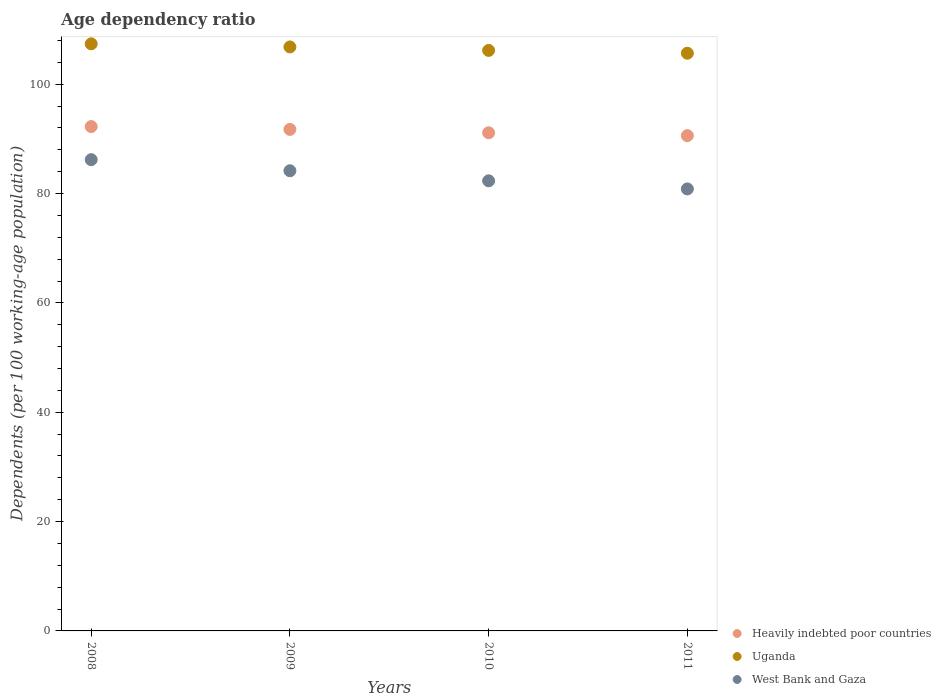Is the number of dotlines equal to the number of legend labels?
Your answer should be very brief. Yes. What is the age dependency ratio in in Uganda in 2009?
Offer a terse response. 106.83. Across all years, what is the maximum age dependency ratio in in Uganda?
Offer a terse response. 107.39. Across all years, what is the minimum age dependency ratio in in Heavily indebted poor countries?
Give a very brief answer. 90.6. What is the total age dependency ratio in in Uganda in the graph?
Provide a succinct answer. 426.08. What is the difference between the age dependency ratio in in Heavily indebted poor countries in 2009 and that in 2011?
Ensure brevity in your answer.  1.15. What is the difference between the age dependency ratio in in Heavily indebted poor countries in 2011 and the age dependency ratio in in West Bank and Gaza in 2008?
Offer a very short reply. 4.39. What is the average age dependency ratio in in Heavily indebted poor countries per year?
Keep it short and to the point. 91.43. In the year 2010, what is the difference between the age dependency ratio in in Uganda and age dependency ratio in in West Bank and Gaza?
Your answer should be very brief. 23.85. What is the ratio of the age dependency ratio in in West Bank and Gaza in 2010 to that in 2011?
Offer a very short reply. 1.02. Is the difference between the age dependency ratio in in Uganda in 2010 and 2011 greater than the difference between the age dependency ratio in in West Bank and Gaza in 2010 and 2011?
Your answer should be very brief. No. What is the difference between the highest and the second highest age dependency ratio in in Uganda?
Provide a succinct answer. 0.57. What is the difference between the highest and the lowest age dependency ratio in in Heavily indebted poor countries?
Your answer should be very brief. 1.66. In how many years, is the age dependency ratio in in Uganda greater than the average age dependency ratio in in Uganda taken over all years?
Your answer should be compact. 2. Is the sum of the age dependency ratio in in Uganda in 2008 and 2011 greater than the maximum age dependency ratio in in West Bank and Gaza across all years?
Your answer should be compact. Yes. How many dotlines are there?
Provide a succinct answer. 3. Does the graph contain any zero values?
Make the answer very short. No. Does the graph contain grids?
Your response must be concise. No. How many legend labels are there?
Offer a very short reply. 3. How are the legend labels stacked?
Make the answer very short. Vertical. What is the title of the graph?
Keep it short and to the point. Age dependency ratio. What is the label or title of the Y-axis?
Offer a very short reply. Dependents (per 100 working-age population). What is the Dependents (per 100 working-age population) of Heavily indebted poor countries in 2008?
Ensure brevity in your answer.  92.26. What is the Dependents (per 100 working-age population) of Uganda in 2008?
Ensure brevity in your answer.  107.39. What is the Dependents (per 100 working-age population) in West Bank and Gaza in 2008?
Offer a very short reply. 86.2. What is the Dependents (per 100 working-age population) in Heavily indebted poor countries in 2009?
Your response must be concise. 91.74. What is the Dependents (per 100 working-age population) of Uganda in 2009?
Ensure brevity in your answer.  106.83. What is the Dependents (per 100 working-age population) of West Bank and Gaza in 2009?
Offer a very short reply. 84.17. What is the Dependents (per 100 working-age population) in Heavily indebted poor countries in 2010?
Give a very brief answer. 91.12. What is the Dependents (per 100 working-age population) of Uganda in 2010?
Give a very brief answer. 106.19. What is the Dependents (per 100 working-age population) in West Bank and Gaza in 2010?
Provide a succinct answer. 82.33. What is the Dependents (per 100 working-age population) in Heavily indebted poor countries in 2011?
Your answer should be very brief. 90.6. What is the Dependents (per 100 working-age population) of Uganda in 2011?
Ensure brevity in your answer.  105.68. What is the Dependents (per 100 working-age population) of West Bank and Gaza in 2011?
Give a very brief answer. 80.85. Across all years, what is the maximum Dependents (per 100 working-age population) in Heavily indebted poor countries?
Offer a terse response. 92.26. Across all years, what is the maximum Dependents (per 100 working-age population) in Uganda?
Provide a short and direct response. 107.39. Across all years, what is the maximum Dependents (per 100 working-age population) in West Bank and Gaza?
Keep it short and to the point. 86.2. Across all years, what is the minimum Dependents (per 100 working-age population) in Heavily indebted poor countries?
Your answer should be compact. 90.6. Across all years, what is the minimum Dependents (per 100 working-age population) in Uganda?
Your response must be concise. 105.68. Across all years, what is the minimum Dependents (per 100 working-age population) of West Bank and Gaza?
Provide a succinct answer. 80.85. What is the total Dependents (per 100 working-age population) in Heavily indebted poor countries in the graph?
Your response must be concise. 365.72. What is the total Dependents (per 100 working-age population) of Uganda in the graph?
Offer a very short reply. 426.08. What is the total Dependents (per 100 working-age population) in West Bank and Gaza in the graph?
Provide a succinct answer. 333.56. What is the difference between the Dependents (per 100 working-age population) in Heavily indebted poor countries in 2008 and that in 2009?
Offer a very short reply. 0.52. What is the difference between the Dependents (per 100 working-age population) of Uganda in 2008 and that in 2009?
Make the answer very short. 0.57. What is the difference between the Dependents (per 100 working-age population) in West Bank and Gaza in 2008 and that in 2009?
Ensure brevity in your answer.  2.03. What is the difference between the Dependents (per 100 working-age population) of Heavily indebted poor countries in 2008 and that in 2010?
Make the answer very short. 1.14. What is the difference between the Dependents (per 100 working-age population) of Uganda in 2008 and that in 2010?
Offer a very short reply. 1.2. What is the difference between the Dependents (per 100 working-age population) of West Bank and Gaza in 2008 and that in 2010?
Give a very brief answer. 3.87. What is the difference between the Dependents (per 100 working-age population) in Heavily indebted poor countries in 2008 and that in 2011?
Make the answer very short. 1.66. What is the difference between the Dependents (per 100 working-age population) in Uganda in 2008 and that in 2011?
Your answer should be compact. 1.72. What is the difference between the Dependents (per 100 working-age population) in West Bank and Gaza in 2008 and that in 2011?
Provide a short and direct response. 5.35. What is the difference between the Dependents (per 100 working-age population) of Heavily indebted poor countries in 2009 and that in 2010?
Your answer should be compact. 0.62. What is the difference between the Dependents (per 100 working-age population) in Uganda in 2009 and that in 2010?
Ensure brevity in your answer.  0.64. What is the difference between the Dependents (per 100 working-age population) of West Bank and Gaza in 2009 and that in 2010?
Give a very brief answer. 1.84. What is the difference between the Dependents (per 100 working-age population) in Heavily indebted poor countries in 2009 and that in 2011?
Provide a succinct answer. 1.15. What is the difference between the Dependents (per 100 working-age population) in Uganda in 2009 and that in 2011?
Your answer should be compact. 1.15. What is the difference between the Dependents (per 100 working-age population) in West Bank and Gaza in 2009 and that in 2011?
Provide a short and direct response. 3.32. What is the difference between the Dependents (per 100 working-age population) in Heavily indebted poor countries in 2010 and that in 2011?
Give a very brief answer. 0.53. What is the difference between the Dependents (per 100 working-age population) in Uganda in 2010 and that in 2011?
Ensure brevity in your answer.  0.51. What is the difference between the Dependents (per 100 working-age population) of West Bank and Gaza in 2010 and that in 2011?
Your answer should be very brief. 1.48. What is the difference between the Dependents (per 100 working-age population) of Heavily indebted poor countries in 2008 and the Dependents (per 100 working-age population) of Uganda in 2009?
Make the answer very short. -14.57. What is the difference between the Dependents (per 100 working-age population) of Heavily indebted poor countries in 2008 and the Dependents (per 100 working-age population) of West Bank and Gaza in 2009?
Provide a succinct answer. 8.08. What is the difference between the Dependents (per 100 working-age population) of Uganda in 2008 and the Dependents (per 100 working-age population) of West Bank and Gaza in 2009?
Your response must be concise. 23.22. What is the difference between the Dependents (per 100 working-age population) of Heavily indebted poor countries in 2008 and the Dependents (per 100 working-age population) of Uganda in 2010?
Provide a short and direct response. -13.93. What is the difference between the Dependents (per 100 working-age population) in Heavily indebted poor countries in 2008 and the Dependents (per 100 working-age population) in West Bank and Gaza in 2010?
Keep it short and to the point. 9.92. What is the difference between the Dependents (per 100 working-age population) in Uganda in 2008 and the Dependents (per 100 working-age population) in West Bank and Gaza in 2010?
Provide a short and direct response. 25.06. What is the difference between the Dependents (per 100 working-age population) of Heavily indebted poor countries in 2008 and the Dependents (per 100 working-age population) of Uganda in 2011?
Your answer should be very brief. -13.42. What is the difference between the Dependents (per 100 working-age population) in Heavily indebted poor countries in 2008 and the Dependents (per 100 working-age population) in West Bank and Gaza in 2011?
Your answer should be very brief. 11.41. What is the difference between the Dependents (per 100 working-age population) of Uganda in 2008 and the Dependents (per 100 working-age population) of West Bank and Gaza in 2011?
Provide a short and direct response. 26.54. What is the difference between the Dependents (per 100 working-age population) in Heavily indebted poor countries in 2009 and the Dependents (per 100 working-age population) in Uganda in 2010?
Your response must be concise. -14.45. What is the difference between the Dependents (per 100 working-age population) of Heavily indebted poor countries in 2009 and the Dependents (per 100 working-age population) of West Bank and Gaza in 2010?
Ensure brevity in your answer.  9.41. What is the difference between the Dependents (per 100 working-age population) of Uganda in 2009 and the Dependents (per 100 working-age population) of West Bank and Gaza in 2010?
Offer a terse response. 24.49. What is the difference between the Dependents (per 100 working-age population) of Heavily indebted poor countries in 2009 and the Dependents (per 100 working-age population) of Uganda in 2011?
Offer a very short reply. -13.93. What is the difference between the Dependents (per 100 working-age population) of Heavily indebted poor countries in 2009 and the Dependents (per 100 working-age population) of West Bank and Gaza in 2011?
Give a very brief answer. 10.89. What is the difference between the Dependents (per 100 working-age population) in Uganda in 2009 and the Dependents (per 100 working-age population) in West Bank and Gaza in 2011?
Ensure brevity in your answer.  25.97. What is the difference between the Dependents (per 100 working-age population) of Heavily indebted poor countries in 2010 and the Dependents (per 100 working-age population) of Uganda in 2011?
Offer a terse response. -14.55. What is the difference between the Dependents (per 100 working-age population) in Heavily indebted poor countries in 2010 and the Dependents (per 100 working-age population) in West Bank and Gaza in 2011?
Your answer should be compact. 10.27. What is the difference between the Dependents (per 100 working-age population) of Uganda in 2010 and the Dependents (per 100 working-age population) of West Bank and Gaza in 2011?
Give a very brief answer. 25.34. What is the average Dependents (per 100 working-age population) in Heavily indebted poor countries per year?
Your answer should be compact. 91.43. What is the average Dependents (per 100 working-age population) in Uganda per year?
Your response must be concise. 106.52. What is the average Dependents (per 100 working-age population) of West Bank and Gaza per year?
Make the answer very short. 83.39. In the year 2008, what is the difference between the Dependents (per 100 working-age population) in Heavily indebted poor countries and Dependents (per 100 working-age population) in Uganda?
Provide a short and direct response. -15.14. In the year 2008, what is the difference between the Dependents (per 100 working-age population) in Heavily indebted poor countries and Dependents (per 100 working-age population) in West Bank and Gaza?
Give a very brief answer. 6.05. In the year 2008, what is the difference between the Dependents (per 100 working-age population) of Uganda and Dependents (per 100 working-age population) of West Bank and Gaza?
Keep it short and to the point. 21.19. In the year 2009, what is the difference between the Dependents (per 100 working-age population) of Heavily indebted poor countries and Dependents (per 100 working-age population) of Uganda?
Provide a short and direct response. -15.08. In the year 2009, what is the difference between the Dependents (per 100 working-age population) of Heavily indebted poor countries and Dependents (per 100 working-age population) of West Bank and Gaza?
Provide a short and direct response. 7.57. In the year 2009, what is the difference between the Dependents (per 100 working-age population) of Uganda and Dependents (per 100 working-age population) of West Bank and Gaza?
Ensure brevity in your answer.  22.65. In the year 2010, what is the difference between the Dependents (per 100 working-age population) in Heavily indebted poor countries and Dependents (per 100 working-age population) in Uganda?
Give a very brief answer. -15.07. In the year 2010, what is the difference between the Dependents (per 100 working-age population) of Heavily indebted poor countries and Dependents (per 100 working-age population) of West Bank and Gaza?
Your answer should be very brief. 8.79. In the year 2010, what is the difference between the Dependents (per 100 working-age population) of Uganda and Dependents (per 100 working-age population) of West Bank and Gaza?
Your response must be concise. 23.85. In the year 2011, what is the difference between the Dependents (per 100 working-age population) in Heavily indebted poor countries and Dependents (per 100 working-age population) in Uganda?
Offer a terse response. -15.08. In the year 2011, what is the difference between the Dependents (per 100 working-age population) in Heavily indebted poor countries and Dependents (per 100 working-age population) in West Bank and Gaza?
Your answer should be very brief. 9.74. In the year 2011, what is the difference between the Dependents (per 100 working-age population) in Uganda and Dependents (per 100 working-age population) in West Bank and Gaza?
Keep it short and to the point. 24.82. What is the ratio of the Dependents (per 100 working-age population) of Heavily indebted poor countries in 2008 to that in 2009?
Offer a very short reply. 1.01. What is the ratio of the Dependents (per 100 working-age population) of West Bank and Gaza in 2008 to that in 2009?
Your response must be concise. 1.02. What is the ratio of the Dependents (per 100 working-age population) in Heavily indebted poor countries in 2008 to that in 2010?
Offer a terse response. 1.01. What is the ratio of the Dependents (per 100 working-age population) of Uganda in 2008 to that in 2010?
Your answer should be compact. 1.01. What is the ratio of the Dependents (per 100 working-age population) of West Bank and Gaza in 2008 to that in 2010?
Provide a succinct answer. 1.05. What is the ratio of the Dependents (per 100 working-age population) in Heavily indebted poor countries in 2008 to that in 2011?
Offer a terse response. 1.02. What is the ratio of the Dependents (per 100 working-age population) in Uganda in 2008 to that in 2011?
Provide a short and direct response. 1.02. What is the ratio of the Dependents (per 100 working-age population) in West Bank and Gaza in 2008 to that in 2011?
Keep it short and to the point. 1.07. What is the ratio of the Dependents (per 100 working-age population) in Heavily indebted poor countries in 2009 to that in 2010?
Your answer should be very brief. 1.01. What is the ratio of the Dependents (per 100 working-age population) of Uganda in 2009 to that in 2010?
Provide a succinct answer. 1.01. What is the ratio of the Dependents (per 100 working-age population) in West Bank and Gaza in 2009 to that in 2010?
Your answer should be compact. 1.02. What is the ratio of the Dependents (per 100 working-age population) in Heavily indebted poor countries in 2009 to that in 2011?
Your answer should be very brief. 1.01. What is the ratio of the Dependents (per 100 working-age population) in Uganda in 2009 to that in 2011?
Offer a very short reply. 1.01. What is the ratio of the Dependents (per 100 working-age population) in West Bank and Gaza in 2009 to that in 2011?
Your answer should be very brief. 1.04. What is the ratio of the Dependents (per 100 working-age population) in West Bank and Gaza in 2010 to that in 2011?
Keep it short and to the point. 1.02. What is the difference between the highest and the second highest Dependents (per 100 working-age population) in Heavily indebted poor countries?
Provide a succinct answer. 0.52. What is the difference between the highest and the second highest Dependents (per 100 working-age population) in Uganda?
Keep it short and to the point. 0.57. What is the difference between the highest and the second highest Dependents (per 100 working-age population) of West Bank and Gaza?
Keep it short and to the point. 2.03. What is the difference between the highest and the lowest Dependents (per 100 working-age population) in Heavily indebted poor countries?
Your answer should be compact. 1.66. What is the difference between the highest and the lowest Dependents (per 100 working-age population) in Uganda?
Your answer should be compact. 1.72. What is the difference between the highest and the lowest Dependents (per 100 working-age population) in West Bank and Gaza?
Provide a succinct answer. 5.35. 